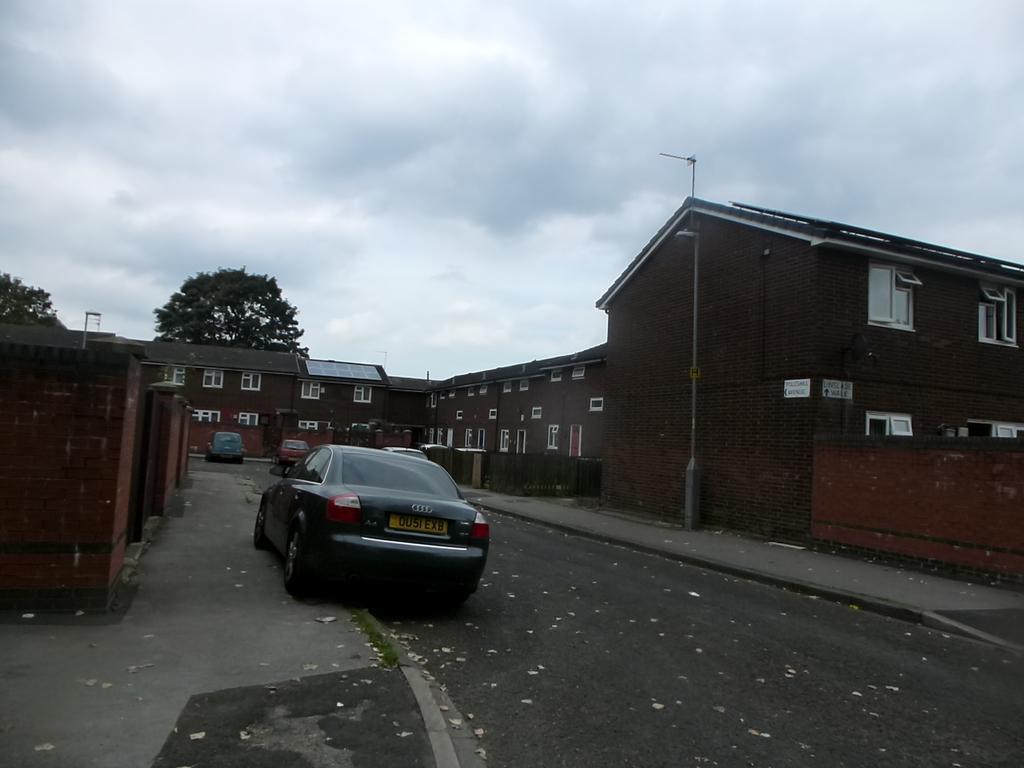Can you describe this image briefly? In this image we can see buildings, motor vehicles on the road, shredded leaves on the road, street poles, street lights, trees and sky with clouds. 